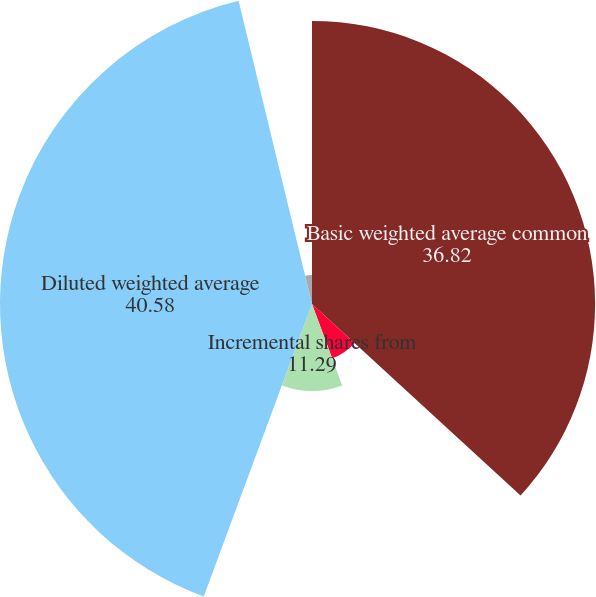<chart> <loc_0><loc_0><loc_500><loc_500><pie_chart><fcel>Basic weighted average common<fcel>Weighted average common stock<fcel>Incremental shares from<fcel>Diluted weighted average<fcel>Outstanding stock options<fcel>Restricted stock units<nl><fcel>36.82%<fcel>7.53%<fcel>11.29%<fcel>40.58%<fcel>3.77%<fcel>0.01%<nl></chart> 